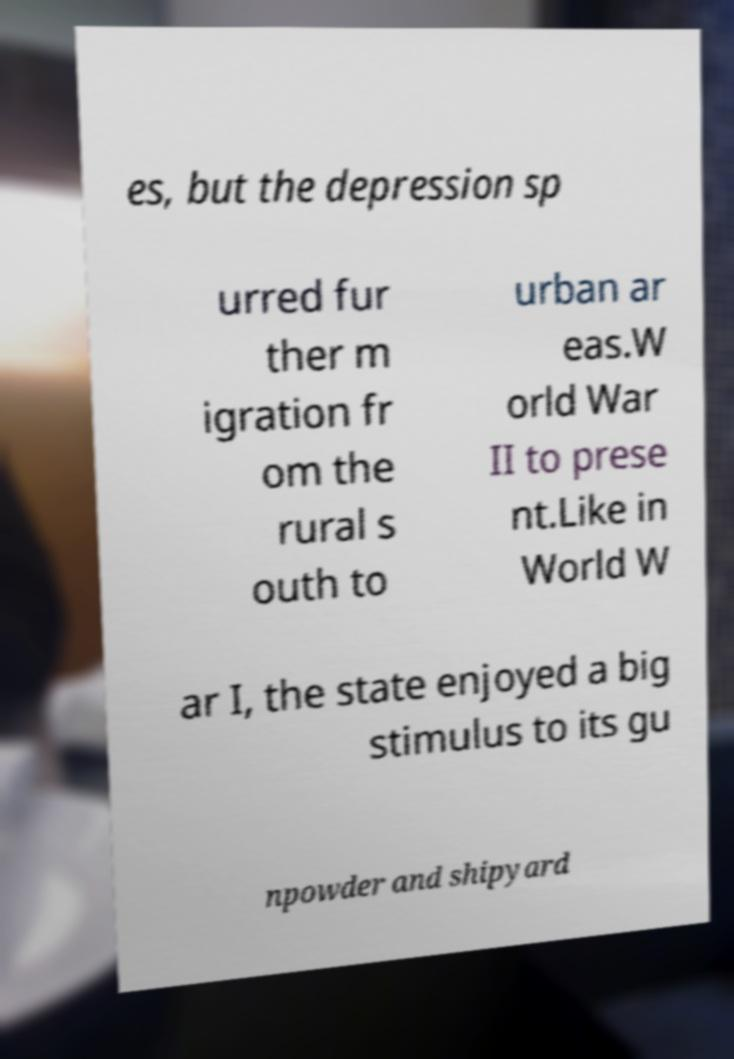Please identify and transcribe the text found in this image. es, but the depression sp urred fur ther m igration fr om the rural s outh to urban ar eas.W orld War II to prese nt.Like in World W ar I, the state enjoyed a big stimulus to its gu npowder and shipyard 